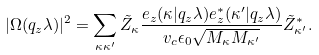<formula> <loc_0><loc_0><loc_500><loc_500>| \Omega ( q _ { z } \lambda ) | ^ { 2 } = \sum _ { \kappa \kappa ^ { \prime } } \tilde { Z } _ { \kappa } \frac { e _ { z } ( \kappa | q _ { z } \lambda ) e ^ { * } _ { z } ( \kappa ^ { \prime } | q _ { z } \lambda ) } { v _ { c } \epsilon _ { 0 } \sqrt { M _ { \kappa } M _ { \kappa ^ { \prime } } } } \tilde { Z } ^ { * } _ { \kappa ^ { \prime } } .</formula> 